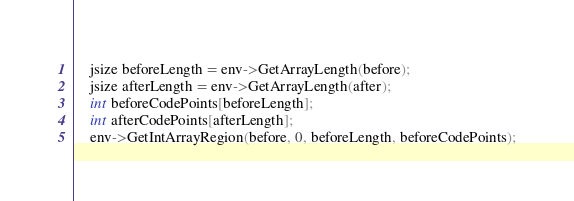<code> <loc_0><loc_0><loc_500><loc_500><_C++_>    jsize beforeLength = env->GetArrayLength(before);
    jsize afterLength = env->GetArrayLength(after);
    int beforeCodePoints[beforeLength];
    int afterCodePoints[afterLength];
    env->GetIntArrayRegion(before, 0, beforeLength, beforeCodePoints);</code> 